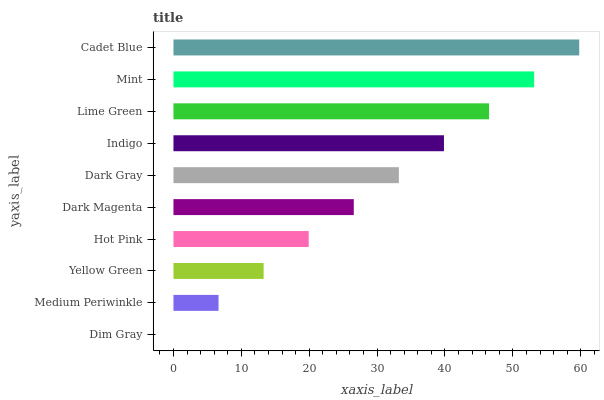Is Dim Gray the minimum?
Answer yes or no. Yes. Is Cadet Blue the maximum?
Answer yes or no. Yes. Is Medium Periwinkle the minimum?
Answer yes or no. No. Is Medium Periwinkle the maximum?
Answer yes or no. No. Is Medium Periwinkle greater than Dim Gray?
Answer yes or no. Yes. Is Dim Gray less than Medium Periwinkle?
Answer yes or no. Yes. Is Dim Gray greater than Medium Periwinkle?
Answer yes or no. No. Is Medium Periwinkle less than Dim Gray?
Answer yes or no. No. Is Dark Gray the high median?
Answer yes or no. Yes. Is Dark Magenta the low median?
Answer yes or no. Yes. Is Indigo the high median?
Answer yes or no. No. Is Dim Gray the low median?
Answer yes or no. No. 